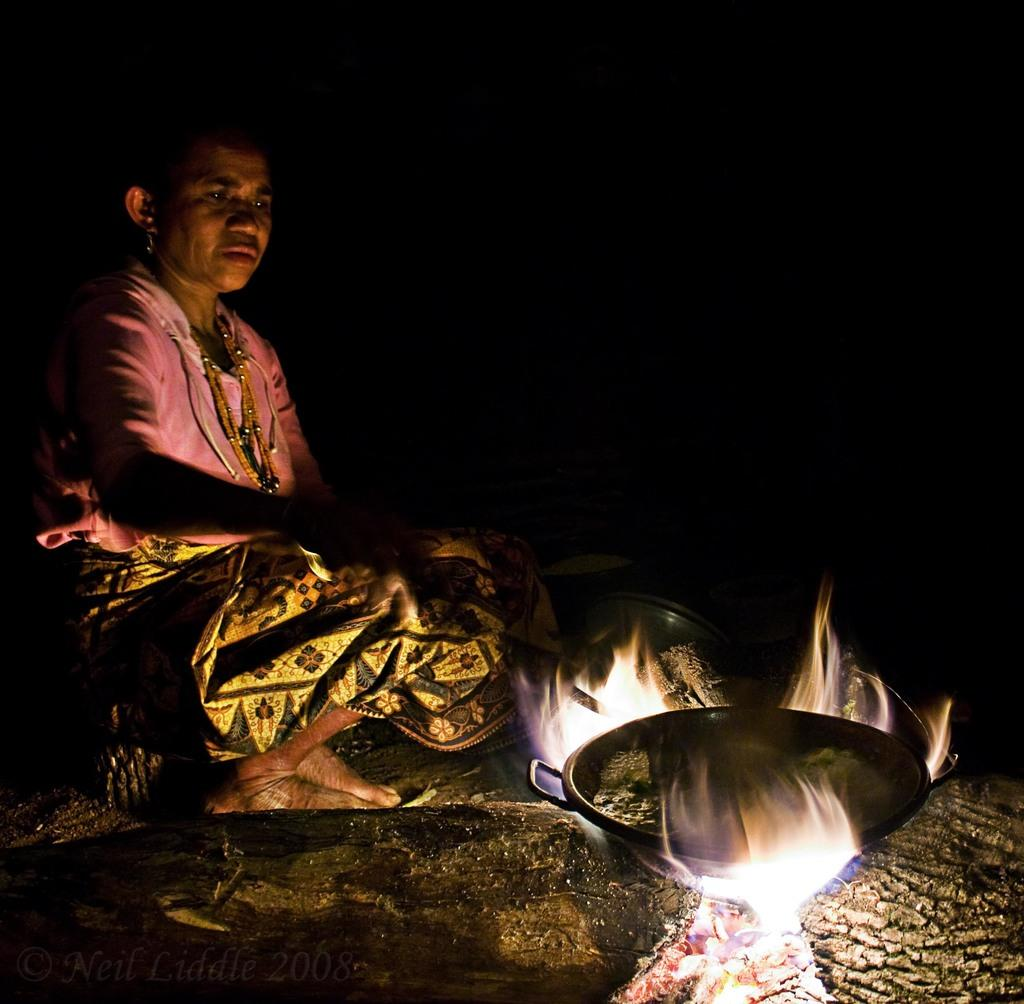What can be seen in the bottom right corner of the image? There is fire in the bottom right corner of the image. What is placed on the fire? There is a bowl on the fire. What is the woman in the middle of the image doing? The woman is sitting in the middle of the image and holding a spoon. What type of flag is the writer using to measure the distance in the image? There is no flag or writer present in the image, and no measuring activity is depicted. 